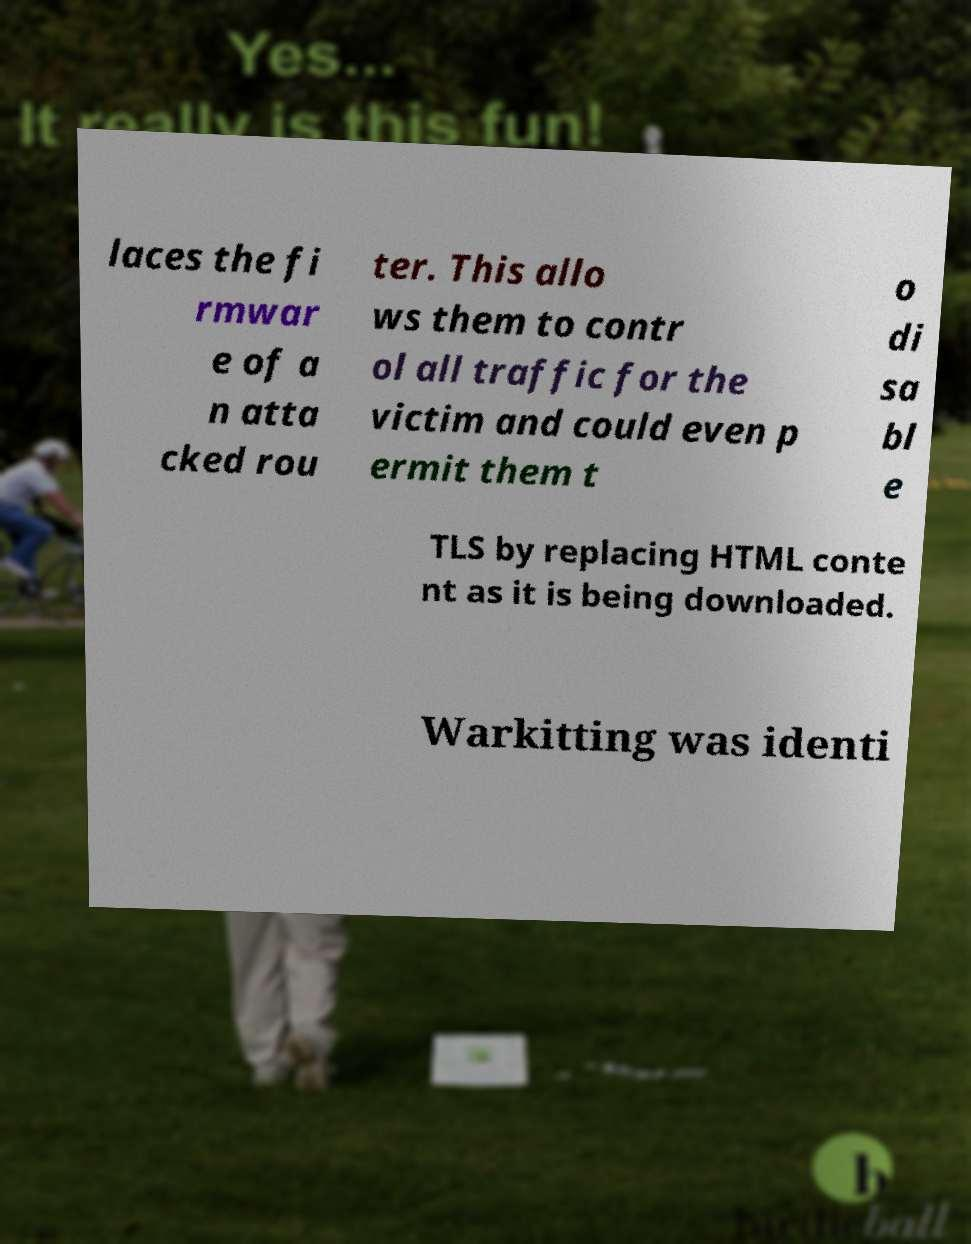Could you extract and type out the text from this image? laces the fi rmwar e of a n atta cked rou ter. This allo ws them to contr ol all traffic for the victim and could even p ermit them t o di sa bl e TLS by replacing HTML conte nt as it is being downloaded. Warkitting was identi 